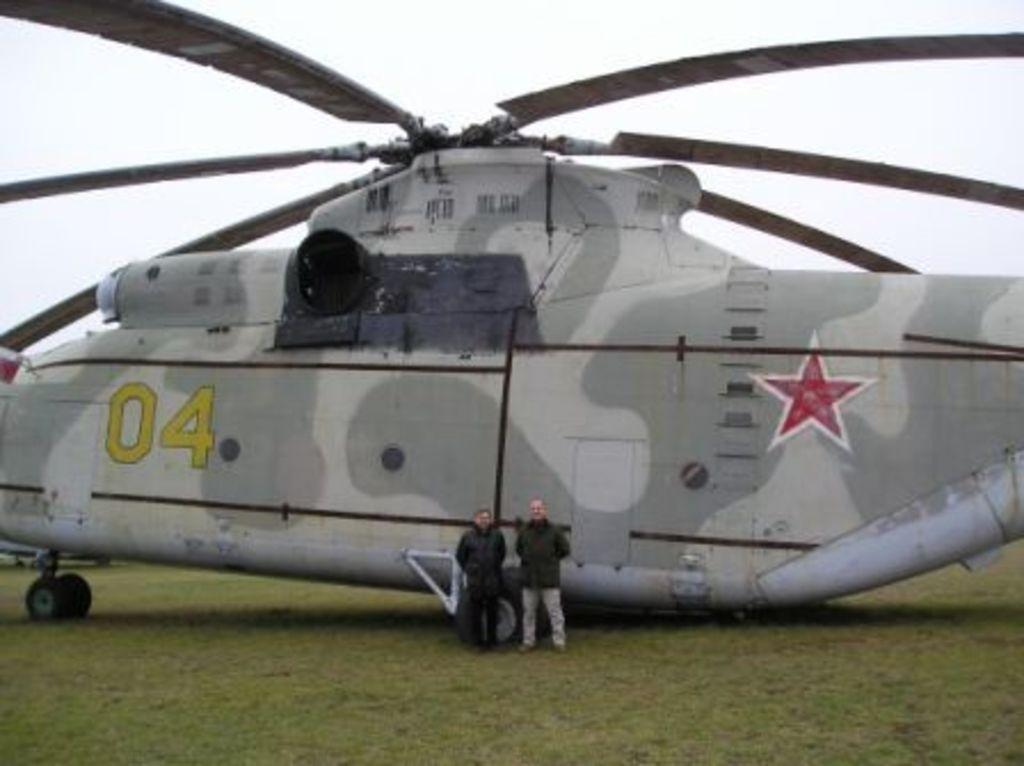Provide a one-sentence caption for the provided image. Two people standing in front of a huge chopper with the numbers 04 on it. 